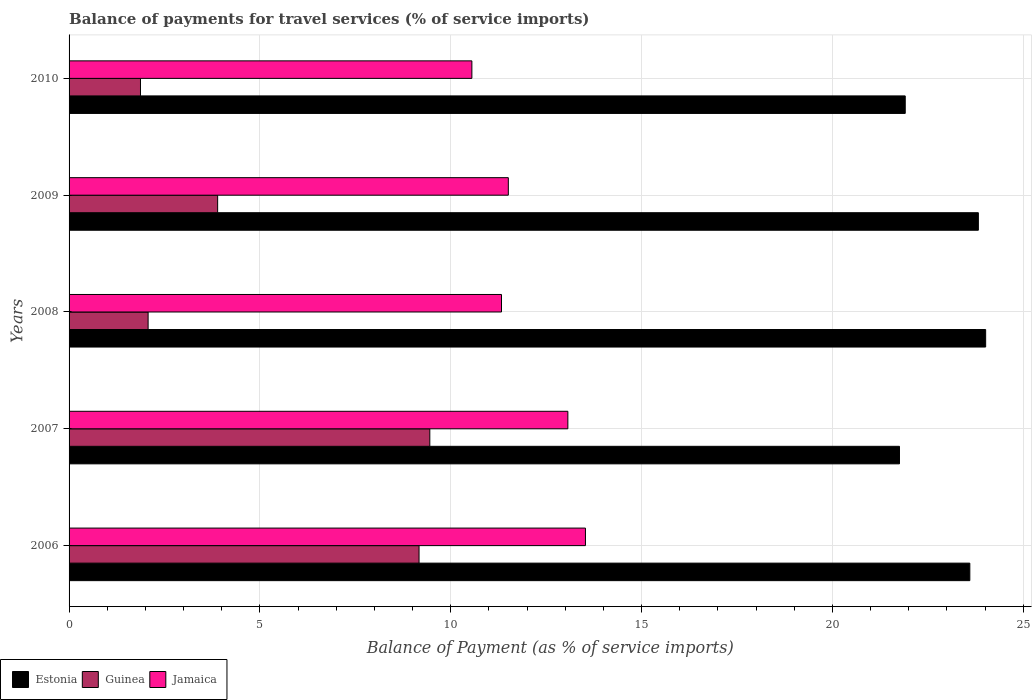How many different coloured bars are there?
Make the answer very short. 3. How many groups of bars are there?
Your answer should be compact. 5. Are the number of bars per tick equal to the number of legend labels?
Provide a short and direct response. Yes. How many bars are there on the 4th tick from the top?
Ensure brevity in your answer.  3. In how many cases, is the number of bars for a given year not equal to the number of legend labels?
Your answer should be very brief. 0. What is the balance of payments for travel services in Jamaica in 2009?
Offer a terse response. 11.51. Across all years, what is the maximum balance of payments for travel services in Jamaica?
Your response must be concise. 13.53. Across all years, what is the minimum balance of payments for travel services in Jamaica?
Keep it short and to the point. 10.55. In which year was the balance of payments for travel services in Jamaica minimum?
Offer a terse response. 2010. What is the total balance of payments for travel services in Guinea in the graph?
Your answer should be compact. 26.45. What is the difference between the balance of payments for travel services in Jamaica in 2006 and that in 2007?
Provide a short and direct response. 0.46. What is the difference between the balance of payments for travel services in Jamaica in 2009 and the balance of payments for travel services in Estonia in 2008?
Ensure brevity in your answer.  -12.51. What is the average balance of payments for travel services in Estonia per year?
Keep it short and to the point. 23.02. In the year 2006, what is the difference between the balance of payments for travel services in Guinea and balance of payments for travel services in Estonia?
Offer a terse response. -14.43. In how many years, is the balance of payments for travel services in Jamaica greater than 22 %?
Keep it short and to the point. 0. What is the ratio of the balance of payments for travel services in Estonia in 2006 to that in 2010?
Your answer should be very brief. 1.08. Is the difference between the balance of payments for travel services in Guinea in 2008 and 2009 greater than the difference between the balance of payments for travel services in Estonia in 2008 and 2009?
Offer a very short reply. No. What is the difference between the highest and the second highest balance of payments for travel services in Guinea?
Make the answer very short. 0.28. What is the difference between the highest and the lowest balance of payments for travel services in Guinea?
Provide a short and direct response. 7.58. In how many years, is the balance of payments for travel services in Guinea greater than the average balance of payments for travel services in Guinea taken over all years?
Your answer should be very brief. 2. What does the 3rd bar from the top in 2007 represents?
Make the answer very short. Estonia. What does the 3rd bar from the bottom in 2007 represents?
Keep it short and to the point. Jamaica. Is it the case that in every year, the sum of the balance of payments for travel services in Estonia and balance of payments for travel services in Jamaica is greater than the balance of payments for travel services in Guinea?
Ensure brevity in your answer.  Yes. Are all the bars in the graph horizontal?
Your response must be concise. Yes. Are the values on the major ticks of X-axis written in scientific E-notation?
Provide a succinct answer. No. Does the graph contain any zero values?
Provide a short and direct response. No. Does the graph contain grids?
Give a very brief answer. Yes. How many legend labels are there?
Ensure brevity in your answer.  3. What is the title of the graph?
Provide a short and direct response. Balance of payments for travel services (% of service imports). What is the label or title of the X-axis?
Provide a short and direct response. Balance of Payment (as % of service imports). What is the Balance of Payment (as % of service imports) of Estonia in 2006?
Your answer should be very brief. 23.6. What is the Balance of Payment (as % of service imports) in Guinea in 2006?
Provide a short and direct response. 9.17. What is the Balance of Payment (as % of service imports) in Jamaica in 2006?
Keep it short and to the point. 13.53. What is the Balance of Payment (as % of service imports) of Estonia in 2007?
Provide a short and direct response. 21.76. What is the Balance of Payment (as % of service imports) in Guinea in 2007?
Your answer should be very brief. 9.45. What is the Balance of Payment (as % of service imports) in Jamaica in 2007?
Offer a very short reply. 13.07. What is the Balance of Payment (as % of service imports) in Estonia in 2008?
Offer a very short reply. 24.01. What is the Balance of Payment (as % of service imports) of Guinea in 2008?
Provide a succinct answer. 2.07. What is the Balance of Payment (as % of service imports) of Jamaica in 2008?
Ensure brevity in your answer.  11.33. What is the Balance of Payment (as % of service imports) of Estonia in 2009?
Your response must be concise. 23.82. What is the Balance of Payment (as % of service imports) of Guinea in 2009?
Offer a terse response. 3.89. What is the Balance of Payment (as % of service imports) of Jamaica in 2009?
Ensure brevity in your answer.  11.51. What is the Balance of Payment (as % of service imports) in Estonia in 2010?
Ensure brevity in your answer.  21.91. What is the Balance of Payment (as % of service imports) of Guinea in 2010?
Your response must be concise. 1.87. What is the Balance of Payment (as % of service imports) of Jamaica in 2010?
Your response must be concise. 10.55. Across all years, what is the maximum Balance of Payment (as % of service imports) in Estonia?
Ensure brevity in your answer.  24.01. Across all years, what is the maximum Balance of Payment (as % of service imports) in Guinea?
Your answer should be very brief. 9.45. Across all years, what is the maximum Balance of Payment (as % of service imports) of Jamaica?
Your answer should be very brief. 13.53. Across all years, what is the minimum Balance of Payment (as % of service imports) in Estonia?
Ensure brevity in your answer.  21.76. Across all years, what is the minimum Balance of Payment (as % of service imports) of Guinea?
Offer a terse response. 1.87. Across all years, what is the minimum Balance of Payment (as % of service imports) of Jamaica?
Provide a succinct answer. 10.55. What is the total Balance of Payment (as % of service imports) in Estonia in the graph?
Provide a short and direct response. 115.1. What is the total Balance of Payment (as % of service imports) of Guinea in the graph?
Ensure brevity in your answer.  26.45. What is the total Balance of Payment (as % of service imports) of Jamaica in the graph?
Provide a succinct answer. 59.99. What is the difference between the Balance of Payment (as % of service imports) of Estonia in 2006 and that in 2007?
Make the answer very short. 1.84. What is the difference between the Balance of Payment (as % of service imports) of Guinea in 2006 and that in 2007?
Ensure brevity in your answer.  -0.28. What is the difference between the Balance of Payment (as % of service imports) of Jamaica in 2006 and that in 2007?
Offer a terse response. 0.46. What is the difference between the Balance of Payment (as % of service imports) in Estonia in 2006 and that in 2008?
Your answer should be very brief. -0.41. What is the difference between the Balance of Payment (as % of service imports) in Guinea in 2006 and that in 2008?
Your answer should be very brief. 7.1. What is the difference between the Balance of Payment (as % of service imports) in Jamaica in 2006 and that in 2008?
Your response must be concise. 2.2. What is the difference between the Balance of Payment (as % of service imports) of Estonia in 2006 and that in 2009?
Provide a succinct answer. -0.22. What is the difference between the Balance of Payment (as % of service imports) in Guinea in 2006 and that in 2009?
Your response must be concise. 5.28. What is the difference between the Balance of Payment (as % of service imports) of Jamaica in 2006 and that in 2009?
Give a very brief answer. 2.02. What is the difference between the Balance of Payment (as % of service imports) of Estonia in 2006 and that in 2010?
Your answer should be compact. 1.69. What is the difference between the Balance of Payment (as % of service imports) of Guinea in 2006 and that in 2010?
Ensure brevity in your answer.  7.3. What is the difference between the Balance of Payment (as % of service imports) of Jamaica in 2006 and that in 2010?
Your answer should be very brief. 2.98. What is the difference between the Balance of Payment (as % of service imports) of Estonia in 2007 and that in 2008?
Provide a succinct answer. -2.26. What is the difference between the Balance of Payment (as % of service imports) in Guinea in 2007 and that in 2008?
Your answer should be very brief. 7.38. What is the difference between the Balance of Payment (as % of service imports) of Jamaica in 2007 and that in 2008?
Offer a very short reply. 1.74. What is the difference between the Balance of Payment (as % of service imports) of Estonia in 2007 and that in 2009?
Offer a very short reply. -2.07. What is the difference between the Balance of Payment (as % of service imports) of Guinea in 2007 and that in 2009?
Ensure brevity in your answer.  5.56. What is the difference between the Balance of Payment (as % of service imports) in Jamaica in 2007 and that in 2009?
Ensure brevity in your answer.  1.56. What is the difference between the Balance of Payment (as % of service imports) in Estonia in 2007 and that in 2010?
Provide a short and direct response. -0.15. What is the difference between the Balance of Payment (as % of service imports) in Guinea in 2007 and that in 2010?
Offer a terse response. 7.58. What is the difference between the Balance of Payment (as % of service imports) in Jamaica in 2007 and that in 2010?
Make the answer very short. 2.51. What is the difference between the Balance of Payment (as % of service imports) in Estonia in 2008 and that in 2009?
Keep it short and to the point. 0.19. What is the difference between the Balance of Payment (as % of service imports) in Guinea in 2008 and that in 2009?
Offer a terse response. -1.82. What is the difference between the Balance of Payment (as % of service imports) in Jamaica in 2008 and that in 2009?
Your response must be concise. -0.18. What is the difference between the Balance of Payment (as % of service imports) in Estonia in 2008 and that in 2010?
Provide a short and direct response. 2.11. What is the difference between the Balance of Payment (as % of service imports) of Guinea in 2008 and that in 2010?
Offer a very short reply. 0.2. What is the difference between the Balance of Payment (as % of service imports) in Jamaica in 2008 and that in 2010?
Your answer should be compact. 0.78. What is the difference between the Balance of Payment (as % of service imports) in Estonia in 2009 and that in 2010?
Your answer should be very brief. 1.92. What is the difference between the Balance of Payment (as % of service imports) of Guinea in 2009 and that in 2010?
Make the answer very short. 2.02. What is the difference between the Balance of Payment (as % of service imports) of Jamaica in 2009 and that in 2010?
Your answer should be very brief. 0.96. What is the difference between the Balance of Payment (as % of service imports) of Estonia in 2006 and the Balance of Payment (as % of service imports) of Guinea in 2007?
Keep it short and to the point. 14.15. What is the difference between the Balance of Payment (as % of service imports) in Estonia in 2006 and the Balance of Payment (as % of service imports) in Jamaica in 2007?
Your answer should be very brief. 10.53. What is the difference between the Balance of Payment (as % of service imports) of Guinea in 2006 and the Balance of Payment (as % of service imports) of Jamaica in 2007?
Make the answer very short. -3.9. What is the difference between the Balance of Payment (as % of service imports) of Estonia in 2006 and the Balance of Payment (as % of service imports) of Guinea in 2008?
Offer a terse response. 21.53. What is the difference between the Balance of Payment (as % of service imports) of Estonia in 2006 and the Balance of Payment (as % of service imports) of Jamaica in 2008?
Your response must be concise. 12.27. What is the difference between the Balance of Payment (as % of service imports) of Guinea in 2006 and the Balance of Payment (as % of service imports) of Jamaica in 2008?
Make the answer very short. -2.16. What is the difference between the Balance of Payment (as % of service imports) in Estonia in 2006 and the Balance of Payment (as % of service imports) in Guinea in 2009?
Ensure brevity in your answer.  19.71. What is the difference between the Balance of Payment (as % of service imports) of Estonia in 2006 and the Balance of Payment (as % of service imports) of Jamaica in 2009?
Offer a terse response. 12.09. What is the difference between the Balance of Payment (as % of service imports) of Guinea in 2006 and the Balance of Payment (as % of service imports) of Jamaica in 2009?
Keep it short and to the point. -2.34. What is the difference between the Balance of Payment (as % of service imports) in Estonia in 2006 and the Balance of Payment (as % of service imports) in Guinea in 2010?
Make the answer very short. 21.73. What is the difference between the Balance of Payment (as % of service imports) of Estonia in 2006 and the Balance of Payment (as % of service imports) of Jamaica in 2010?
Give a very brief answer. 13.05. What is the difference between the Balance of Payment (as % of service imports) in Guinea in 2006 and the Balance of Payment (as % of service imports) in Jamaica in 2010?
Give a very brief answer. -1.38. What is the difference between the Balance of Payment (as % of service imports) in Estonia in 2007 and the Balance of Payment (as % of service imports) in Guinea in 2008?
Offer a terse response. 19.69. What is the difference between the Balance of Payment (as % of service imports) of Estonia in 2007 and the Balance of Payment (as % of service imports) of Jamaica in 2008?
Provide a succinct answer. 10.43. What is the difference between the Balance of Payment (as % of service imports) in Guinea in 2007 and the Balance of Payment (as % of service imports) in Jamaica in 2008?
Make the answer very short. -1.88. What is the difference between the Balance of Payment (as % of service imports) of Estonia in 2007 and the Balance of Payment (as % of service imports) of Guinea in 2009?
Keep it short and to the point. 17.86. What is the difference between the Balance of Payment (as % of service imports) in Estonia in 2007 and the Balance of Payment (as % of service imports) in Jamaica in 2009?
Make the answer very short. 10.25. What is the difference between the Balance of Payment (as % of service imports) of Guinea in 2007 and the Balance of Payment (as % of service imports) of Jamaica in 2009?
Your response must be concise. -2.06. What is the difference between the Balance of Payment (as % of service imports) in Estonia in 2007 and the Balance of Payment (as % of service imports) in Guinea in 2010?
Keep it short and to the point. 19.89. What is the difference between the Balance of Payment (as % of service imports) of Estonia in 2007 and the Balance of Payment (as % of service imports) of Jamaica in 2010?
Your answer should be compact. 11.2. What is the difference between the Balance of Payment (as % of service imports) of Guinea in 2007 and the Balance of Payment (as % of service imports) of Jamaica in 2010?
Your answer should be compact. -1.1. What is the difference between the Balance of Payment (as % of service imports) of Estonia in 2008 and the Balance of Payment (as % of service imports) of Guinea in 2009?
Make the answer very short. 20.12. What is the difference between the Balance of Payment (as % of service imports) in Estonia in 2008 and the Balance of Payment (as % of service imports) in Jamaica in 2009?
Provide a short and direct response. 12.51. What is the difference between the Balance of Payment (as % of service imports) in Guinea in 2008 and the Balance of Payment (as % of service imports) in Jamaica in 2009?
Provide a succinct answer. -9.44. What is the difference between the Balance of Payment (as % of service imports) in Estonia in 2008 and the Balance of Payment (as % of service imports) in Guinea in 2010?
Provide a short and direct response. 22.14. What is the difference between the Balance of Payment (as % of service imports) in Estonia in 2008 and the Balance of Payment (as % of service imports) in Jamaica in 2010?
Make the answer very short. 13.46. What is the difference between the Balance of Payment (as % of service imports) of Guinea in 2008 and the Balance of Payment (as % of service imports) of Jamaica in 2010?
Keep it short and to the point. -8.48. What is the difference between the Balance of Payment (as % of service imports) of Estonia in 2009 and the Balance of Payment (as % of service imports) of Guinea in 2010?
Your response must be concise. 21.95. What is the difference between the Balance of Payment (as % of service imports) in Estonia in 2009 and the Balance of Payment (as % of service imports) in Jamaica in 2010?
Ensure brevity in your answer.  13.27. What is the difference between the Balance of Payment (as % of service imports) in Guinea in 2009 and the Balance of Payment (as % of service imports) in Jamaica in 2010?
Your answer should be very brief. -6.66. What is the average Balance of Payment (as % of service imports) of Estonia per year?
Give a very brief answer. 23.02. What is the average Balance of Payment (as % of service imports) of Guinea per year?
Give a very brief answer. 5.29. What is the average Balance of Payment (as % of service imports) in Jamaica per year?
Provide a succinct answer. 12. In the year 2006, what is the difference between the Balance of Payment (as % of service imports) of Estonia and Balance of Payment (as % of service imports) of Guinea?
Provide a short and direct response. 14.43. In the year 2006, what is the difference between the Balance of Payment (as % of service imports) of Estonia and Balance of Payment (as % of service imports) of Jamaica?
Your answer should be very brief. 10.07. In the year 2006, what is the difference between the Balance of Payment (as % of service imports) in Guinea and Balance of Payment (as % of service imports) in Jamaica?
Keep it short and to the point. -4.36. In the year 2007, what is the difference between the Balance of Payment (as % of service imports) of Estonia and Balance of Payment (as % of service imports) of Guinea?
Your answer should be compact. 12.31. In the year 2007, what is the difference between the Balance of Payment (as % of service imports) in Estonia and Balance of Payment (as % of service imports) in Jamaica?
Your response must be concise. 8.69. In the year 2007, what is the difference between the Balance of Payment (as % of service imports) in Guinea and Balance of Payment (as % of service imports) in Jamaica?
Give a very brief answer. -3.62. In the year 2008, what is the difference between the Balance of Payment (as % of service imports) of Estonia and Balance of Payment (as % of service imports) of Guinea?
Provide a succinct answer. 21.94. In the year 2008, what is the difference between the Balance of Payment (as % of service imports) of Estonia and Balance of Payment (as % of service imports) of Jamaica?
Give a very brief answer. 12.68. In the year 2008, what is the difference between the Balance of Payment (as % of service imports) of Guinea and Balance of Payment (as % of service imports) of Jamaica?
Your answer should be compact. -9.26. In the year 2009, what is the difference between the Balance of Payment (as % of service imports) in Estonia and Balance of Payment (as % of service imports) in Guinea?
Your answer should be very brief. 19.93. In the year 2009, what is the difference between the Balance of Payment (as % of service imports) in Estonia and Balance of Payment (as % of service imports) in Jamaica?
Ensure brevity in your answer.  12.31. In the year 2009, what is the difference between the Balance of Payment (as % of service imports) of Guinea and Balance of Payment (as % of service imports) of Jamaica?
Ensure brevity in your answer.  -7.62. In the year 2010, what is the difference between the Balance of Payment (as % of service imports) of Estonia and Balance of Payment (as % of service imports) of Guinea?
Ensure brevity in your answer.  20.04. In the year 2010, what is the difference between the Balance of Payment (as % of service imports) in Estonia and Balance of Payment (as % of service imports) in Jamaica?
Make the answer very short. 11.35. In the year 2010, what is the difference between the Balance of Payment (as % of service imports) of Guinea and Balance of Payment (as % of service imports) of Jamaica?
Offer a terse response. -8.68. What is the ratio of the Balance of Payment (as % of service imports) in Estonia in 2006 to that in 2007?
Keep it short and to the point. 1.08. What is the ratio of the Balance of Payment (as % of service imports) in Guinea in 2006 to that in 2007?
Offer a very short reply. 0.97. What is the ratio of the Balance of Payment (as % of service imports) in Jamaica in 2006 to that in 2007?
Offer a very short reply. 1.04. What is the ratio of the Balance of Payment (as % of service imports) in Estonia in 2006 to that in 2008?
Provide a short and direct response. 0.98. What is the ratio of the Balance of Payment (as % of service imports) of Guinea in 2006 to that in 2008?
Ensure brevity in your answer.  4.43. What is the ratio of the Balance of Payment (as % of service imports) of Jamaica in 2006 to that in 2008?
Provide a succinct answer. 1.19. What is the ratio of the Balance of Payment (as % of service imports) of Estonia in 2006 to that in 2009?
Provide a succinct answer. 0.99. What is the ratio of the Balance of Payment (as % of service imports) of Guinea in 2006 to that in 2009?
Make the answer very short. 2.36. What is the ratio of the Balance of Payment (as % of service imports) in Jamaica in 2006 to that in 2009?
Offer a terse response. 1.18. What is the ratio of the Balance of Payment (as % of service imports) of Estonia in 2006 to that in 2010?
Offer a very short reply. 1.08. What is the ratio of the Balance of Payment (as % of service imports) of Guinea in 2006 to that in 2010?
Make the answer very short. 4.9. What is the ratio of the Balance of Payment (as % of service imports) of Jamaica in 2006 to that in 2010?
Provide a succinct answer. 1.28. What is the ratio of the Balance of Payment (as % of service imports) in Estonia in 2007 to that in 2008?
Give a very brief answer. 0.91. What is the ratio of the Balance of Payment (as % of service imports) in Guinea in 2007 to that in 2008?
Your answer should be very brief. 4.56. What is the ratio of the Balance of Payment (as % of service imports) of Jamaica in 2007 to that in 2008?
Your answer should be compact. 1.15. What is the ratio of the Balance of Payment (as % of service imports) of Estonia in 2007 to that in 2009?
Offer a terse response. 0.91. What is the ratio of the Balance of Payment (as % of service imports) of Guinea in 2007 to that in 2009?
Your answer should be compact. 2.43. What is the ratio of the Balance of Payment (as % of service imports) in Jamaica in 2007 to that in 2009?
Make the answer very short. 1.14. What is the ratio of the Balance of Payment (as % of service imports) of Estonia in 2007 to that in 2010?
Offer a terse response. 0.99. What is the ratio of the Balance of Payment (as % of service imports) of Guinea in 2007 to that in 2010?
Make the answer very short. 5.05. What is the ratio of the Balance of Payment (as % of service imports) of Jamaica in 2007 to that in 2010?
Provide a succinct answer. 1.24. What is the ratio of the Balance of Payment (as % of service imports) in Estonia in 2008 to that in 2009?
Provide a succinct answer. 1.01. What is the ratio of the Balance of Payment (as % of service imports) of Guinea in 2008 to that in 2009?
Provide a succinct answer. 0.53. What is the ratio of the Balance of Payment (as % of service imports) in Jamaica in 2008 to that in 2009?
Your answer should be compact. 0.98. What is the ratio of the Balance of Payment (as % of service imports) of Estonia in 2008 to that in 2010?
Your answer should be compact. 1.1. What is the ratio of the Balance of Payment (as % of service imports) of Guinea in 2008 to that in 2010?
Provide a short and direct response. 1.11. What is the ratio of the Balance of Payment (as % of service imports) of Jamaica in 2008 to that in 2010?
Make the answer very short. 1.07. What is the ratio of the Balance of Payment (as % of service imports) in Estonia in 2009 to that in 2010?
Provide a succinct answer. 1.09. What is the ratio of the Balance of Payment (as % of service imports) in Guinea in 2009 to that in 2010?
Offer a very short reply. 2.08. What is the ratio of the Balance of Payment (as % of service imports) of Jamaica in 2009 to that in 2010?
Give a very brief answer. 1.09. What is the difference between the highest and the second highest Balance of Payment (as % of service imports) in Estonia?
Make the answer very short. 0.19. What is the difference between the highest and the second highest Balance of Payment (as % of service imports) of Guinea?
Provide a succinct answer. 0.28. What is the difference between the highest and the second highest Balance of Payment (as % of service imports) in Jamaica?
Ensure brevity in your answer.  0.46. What is the difference between the highest and the lowest Balance of Payment (as % of service imports) in Estonia?
Your response must be concise. 2.26. What is the difference between the highest and the lowest Balance of Payment (as % of service imports) in Guinea?
Offer a terse response. 7.58. What is the difference between the highest and the lowest Balance of Payment (as % of service imports) in Jamaica?
Offer a very short reply. 2.98. 